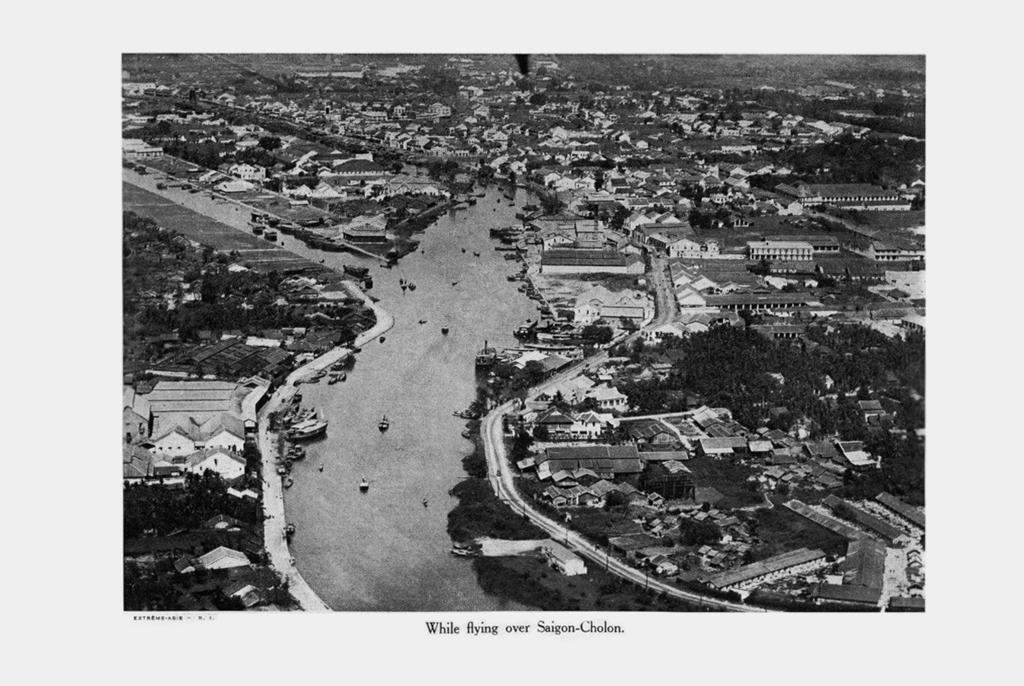What is the color scheme of the image? The image is black and white. What can be seen in the middle of the image? There is a road in the middle of the image. What type of structures are visible in the image? There are houses visible in the image. What other natural elements can be seen in the image? Trees are present in the image. Can you describe the locket that the turkey is wearing in the image? There is no locket or turkey present in the image. What type of pear is hanging from the tree in the image? There is no pear visible in the image; only trees are mentioned. 